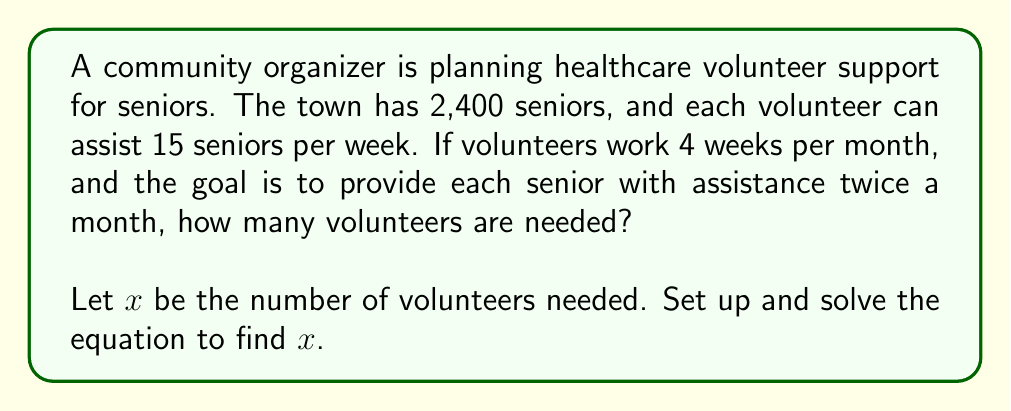Teach me how to tackle this problem. Let's break this problem down step-by-step:

1) First, let's identify the key information:
   - There are 2,400 seniors
   - Each volunteer can assist 15 seniors per week
   - Volunteers work 4 weeks per month
   - Each senior should receive assistance twice a month

2) Let's calculate how many seniors each volunteer can assist per month:
   $15 \text{ seniors/week} \times 4 \text{ weeks/month} = 60 \text{ seniors/month}$

3) Now, we need to consider that each senior should receive assistance twice a month. This effectively doubles the number of assistance sessions needed:
   $2,400 \text{ seniors} \times 2 \text{ visits/month} = 4,800 \text{ assistance sessions/month}$

4) We can now set up our equation. Let $x$ be the number of volunteers needed:
   $60x = 4,800$

   This equation states that the number of seniors each volunteer can assist per month ($60$) multiplied by the number of volunteers ($x$) should equal the total number of assistance sessions needed per month ($4,800$).

5) Solve for $x$:
   $$x = \frac{4,800}{60} = 80$$

Therefore, 80 volunteers are needed to meet the community's goals.
Answer: 80 volunteers 